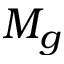<formula> <loc_0><loc_0><loc_500><loc_500>M _ { g }</formula> 